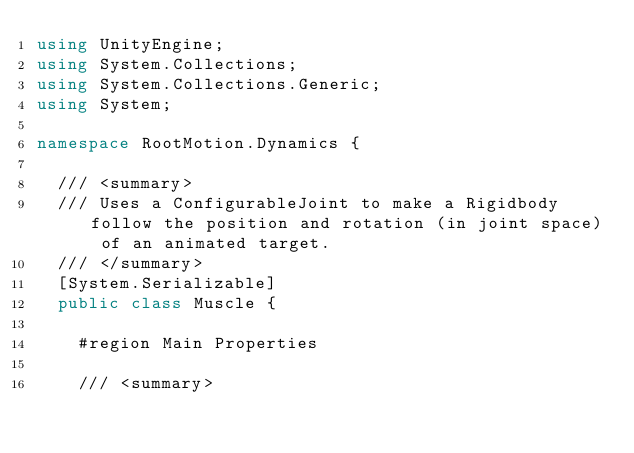<code> <loc_0><loc_0><loc_500><loc_500><_C#_>using UnityEngine;
using System.Collections;
using System.Collections.Generic;
using System;

namespace RootMotion.Dynamics {

	/// <summary>
	/// Uses a ConfigurableJoint to make a Rigidbody follow the position and rotation (in joint space) of an animated target.
	/// </summary>
	[System.Serializable]
	public class Muscle {
		
		#region Main Properties

		/// <summary></code> 